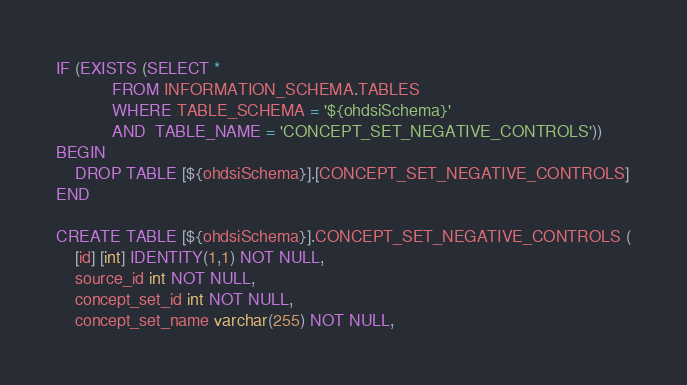Convert code to text. <code><loc_0><loc_0><loc_500><loc_500><_SQL_>IF (EXISTS (SELECT * 
            FROM INFORMATION_SCHEMA.TABLES 
            WHERE TABLE_SCHEMA = '${ohdsiSchema}' 
            AND  TABLE_NAME = 'CONCEPT_SET_NEGATIVE_CONTROLS'))
BEGIN
    DROP TABLE [${ohdsiSchema}].[CONCEPT_SET_NEGATIVE_CONTROLS]
END

CREATE TABLE [${ohdsiSchema}].CONCEPT_SET_NEGATIVE_CONTROLS (
    [id] [int] IDENTITY(1,1) NOT NULL,
    source_id int NOT NULL,
    concept_set_id int NOT NULL,
    concept_set_name varchar(255) NOT NULL,</code> 